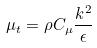<formula> <loc_0><loc_0><loc_500><loc_500>\mu _ { t } = \rho C _ { \mu } \frac { k ^ { 2 } } { \epsilon }</formula> 